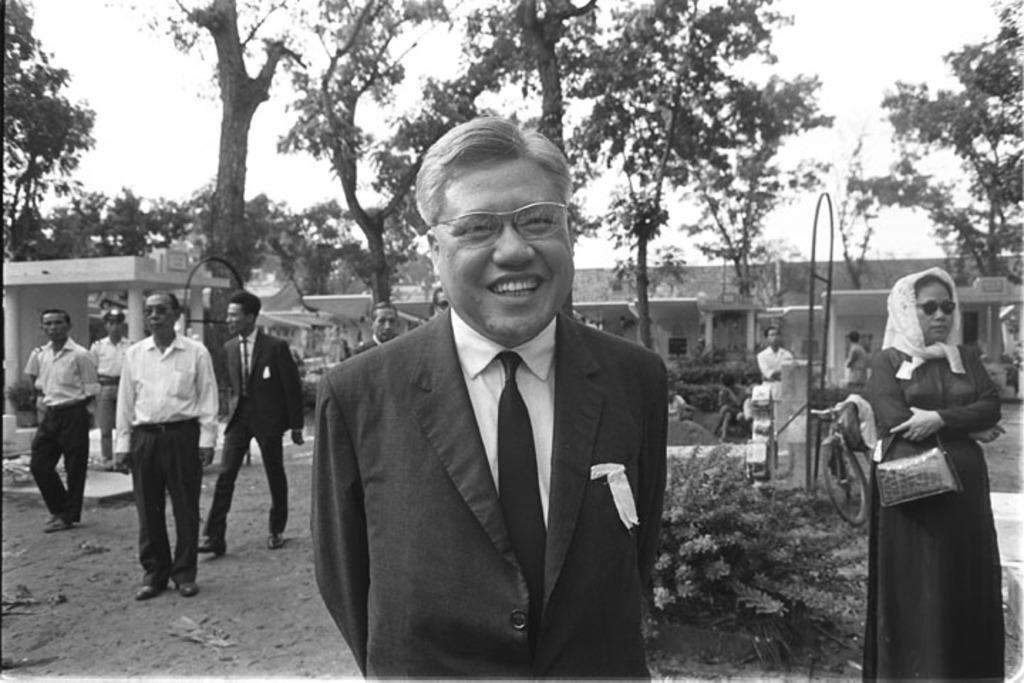Could you give a brief overview of what you see in this image? In this picture I can see few people are on the ground, behind we can see some houses, trees, plants. 